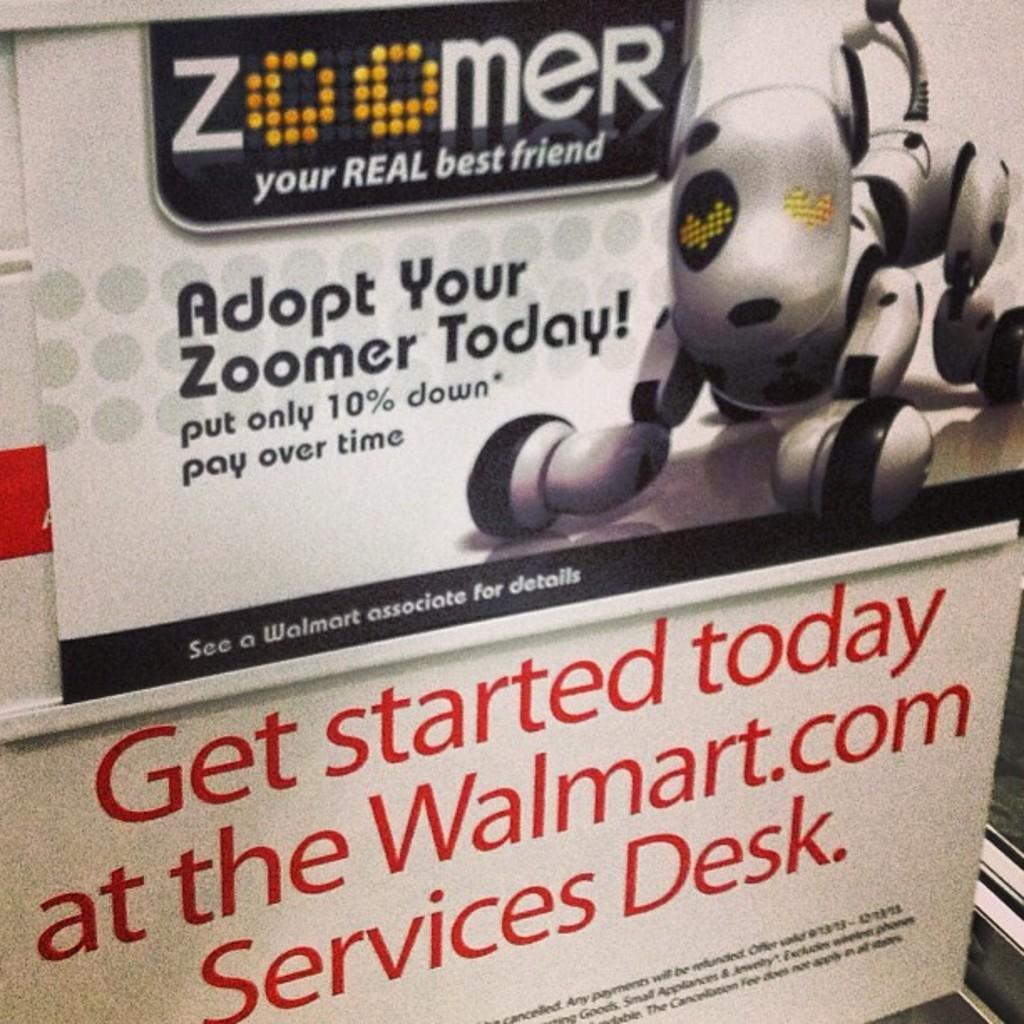<image>
Summarize the visual content of the image. An advertisement for a robotic dog displayed in the store of Walmart. 